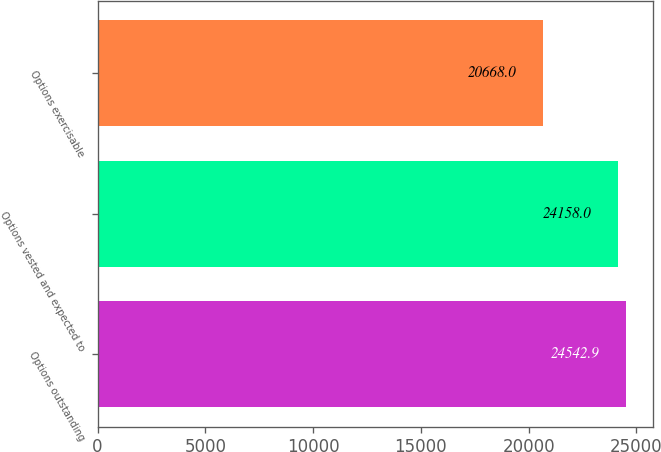Convert chart. <chart><loc_0><loc_0><loc_500><loc_500><bar_chart><fcel>Options outstanding<fcel>Options vested and expected to<fcel>Options exercisable<nl><fcel>24542.9<fcel>24158<fcel>20668<nl></chart> 